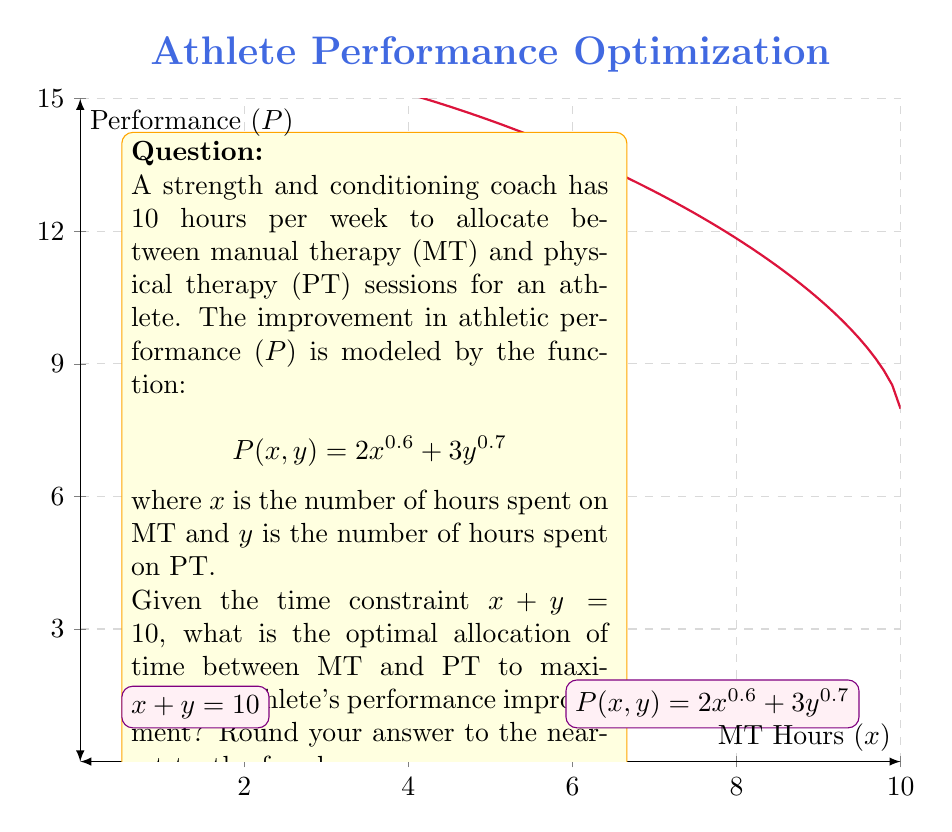Can you answer this question? To solve this optimization problem, we can use the method of Lagrange multipliers:

1) Let $L(x, y, \lambda) = 2x^{0.6} + 3y^{0.7} - \lambda(x + y - 10)$ be the Lagrangian function.

2) Set partial derivatives equal to zero:

   $$\frac{\partial L}{\partial x} = 1.2x^{-0.4} - \lambda = 0$$
   $$\frac{\partial L}{\partial y} = 2.1y^{-0.3} - \lambda = 0$$
   $$\frac{\partial L}{\partial \lambda} = x + y - 10 = 0$$

3) From the first two equations:

   $$1.2x^{-0.4} = 2.1y^{-0.3}$$

4) Simplify:

   $$\frac{x^{0.4}}{y^{0.3}} = \frac{2.1}{1.2} = 1.75$$

5) Raise both sides to the power of 10:

   $$\frac{x^4}{y^3} = 1.75^{10} \approx 269.39$$

6) Let $y = 10 - x$ (from the time constraint) and substitute:

   $$\frac{x^4}{(10-x)^3} = 269.39$$

7) Solve this equation numerically (e.g., using Newton's method or graphical method) to get:

   $$x \approx 4.3$$

8) Therefore, $y = 10 - 4.3 = 5.7$

Rounding to the nearest tenth:
$x = 4.3$ hours for MT
$y = 5.7$ hours for PT
Answer: MT: 4.3 hours, PT: 5.7 hours 